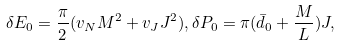Convert formula to latex. <formula><loc_0><loc_0><loc_500><loc_500>\delta E _ { 0 } = \frac { \pi } { 2 } ( v _ { N } M ^ { 2 } + v _ { J } J ^ { 2 } ) , \delta P _ { 0 } = \pi ( \bar { d } _ { 0 } + \frac { M } { L } ) J ,</formula> 